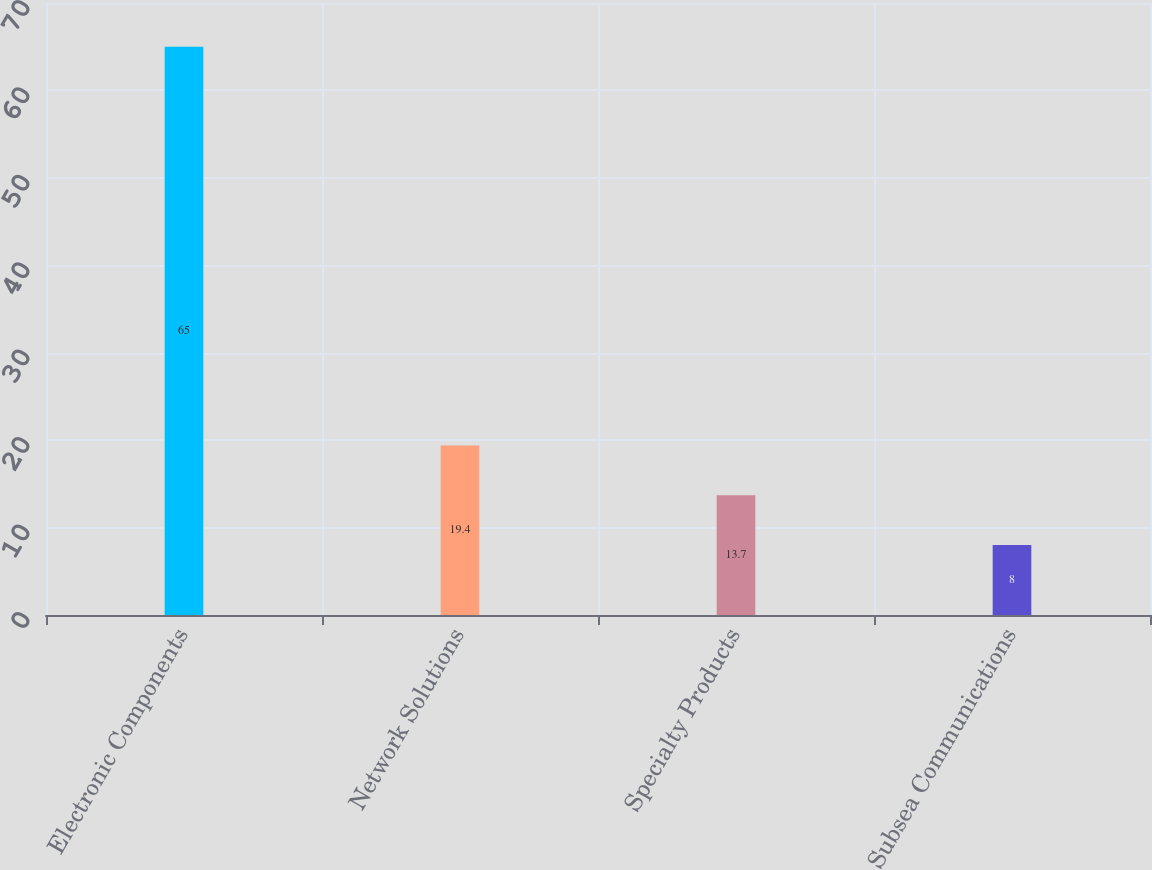Convert chart. <chart><loc_0><loc_0><loc_500><loc_500><bar_chart><fcel>Electronic Components<fcel>Network Solutions<fcel>Specialty Products<fcel>Subsea Communications<nl><fcel>65<fcel>19.4<fcel>13.7<fcel>8<nl></chart> 